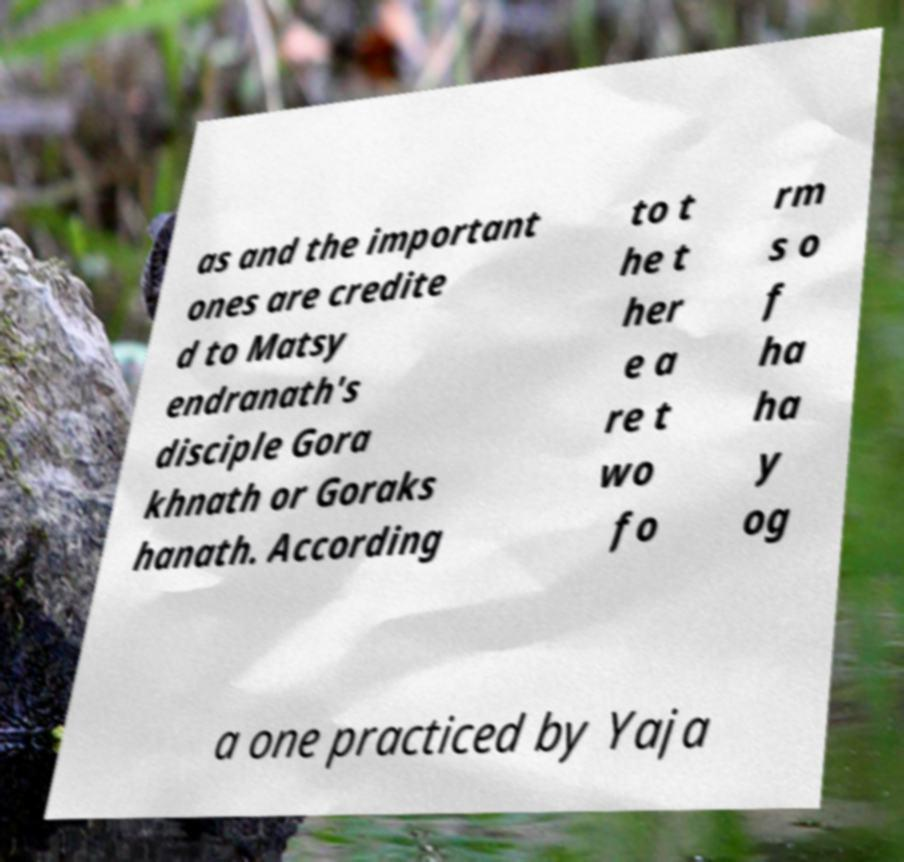Could you assist in decoding the text presented in this image and type it out clearly? as and the important ones are credite d to Matsy endranath's disciple Gora khnath or Goraks hanath. According to t he t her e a re t wo fo rm s o f ha ha y og a one practiced by Yaja 